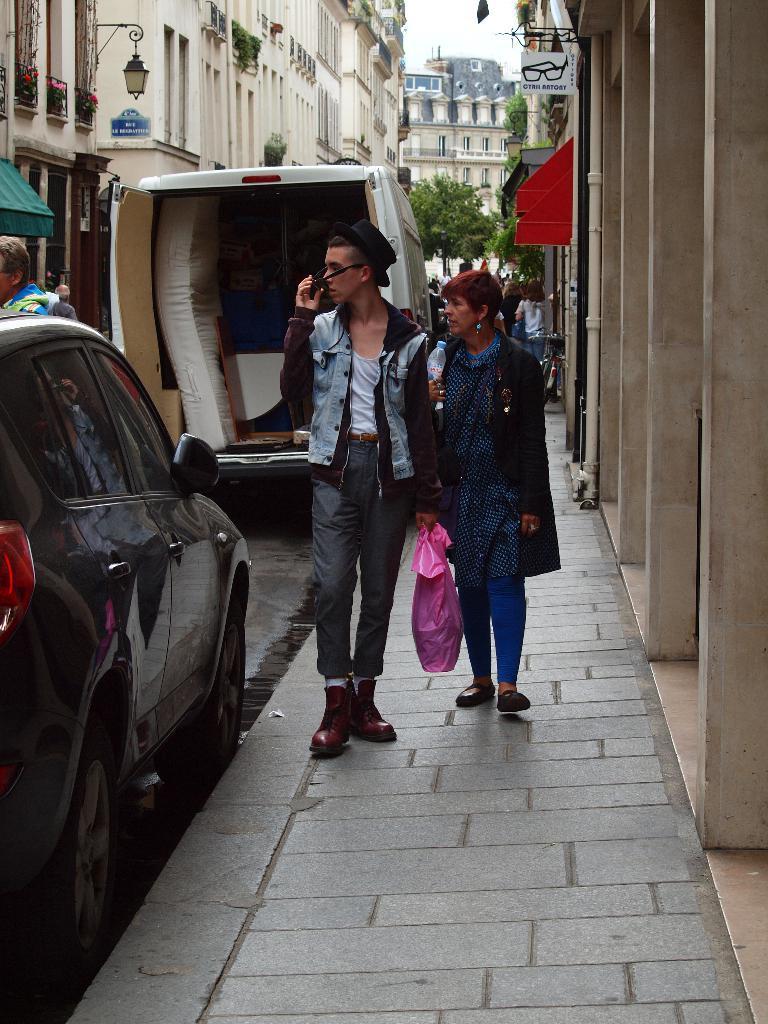Describe this image in one or two sentences. In this image I can see number of people on the footpath. On the left side of the image I can see a road and on it I can see few vehicles and few more people. On the both sides of the road I can see number of buildings, few trees, few plants, few lights and on these boards I can see something is written. In the front I can see one person is holding a pink colour bag. 